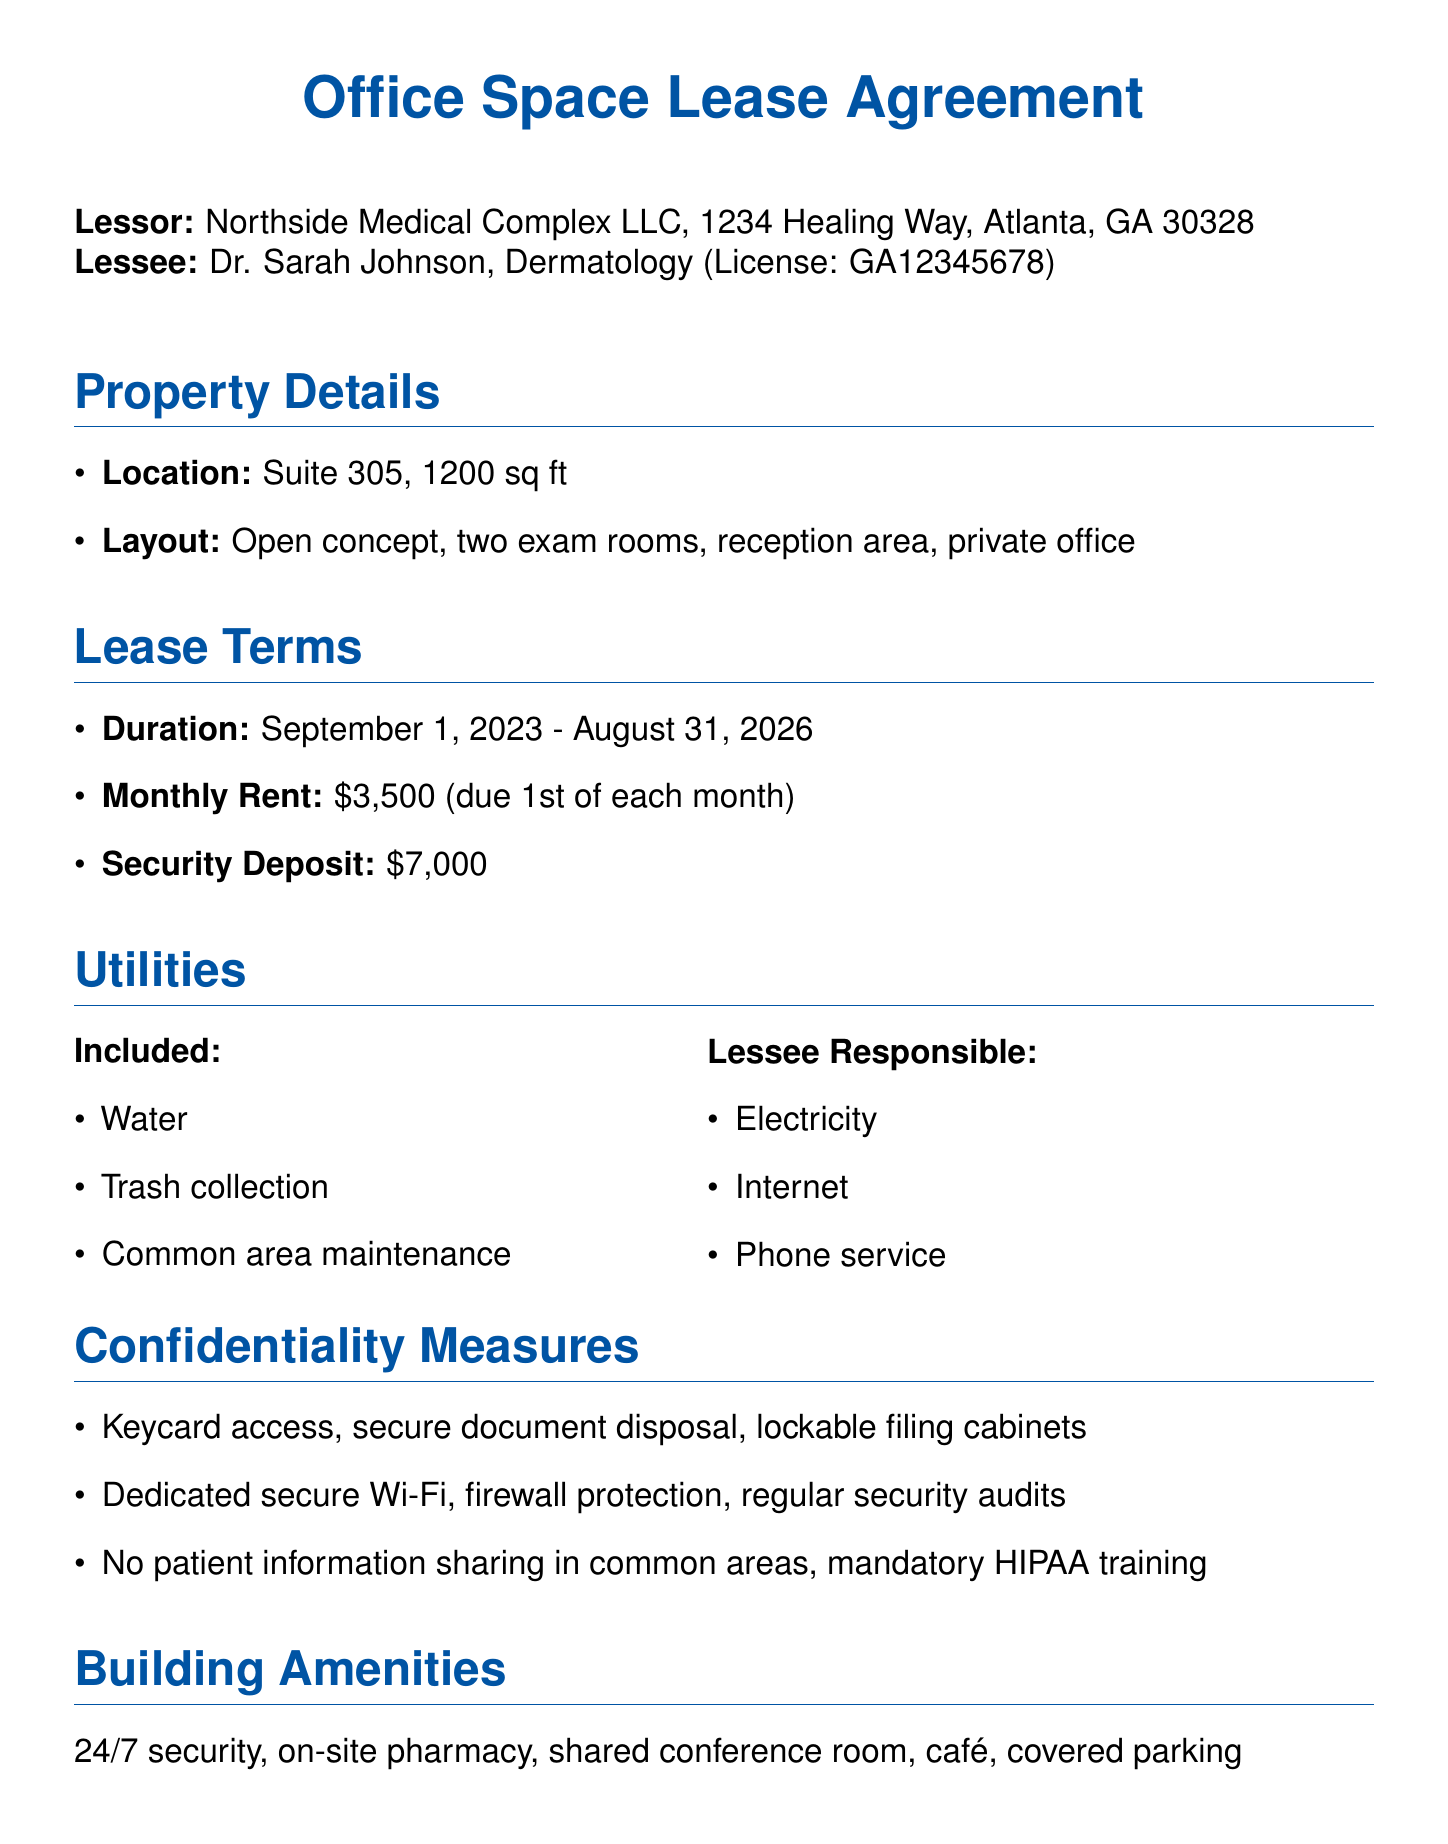What is the name of the lessor? The lessor's name is provided at the beginning of the document.
Answer: Northside Medical Complex LLC What is the monthly rent amount? The monthly rent amount is specified under lease terms in the document.
Answer: $3,500 What is the suite number being leased? The suite number is mentioned in the property details section.
Answer: Suite 305 What utilities are included in the lease? The document lists the utilities included within the utilities section.
Answer: Water, Trash collection, Common area maintenance What is the duration of the lease? The lease duration is found in the lease terms section and is defined by the start and end dates.
Answer: September 1, 2023 - August 31, 2026 What is the early termination fee? The early termination fee is included in the termination clause of the lease.
Answer: 3 months' rent How many days written notice is required for termination? This information is specified in the termination clause of the document.
Answer: 90 days What security measure is mentioned for document disposal? The measure is specified under confidentiality measures in the document.
Answer: Secure document disposal services What type of insurance is required for general liability? The required insurance type and amount are detailed under insurance requirements.
Answer: $2,000,000 per occurrence 